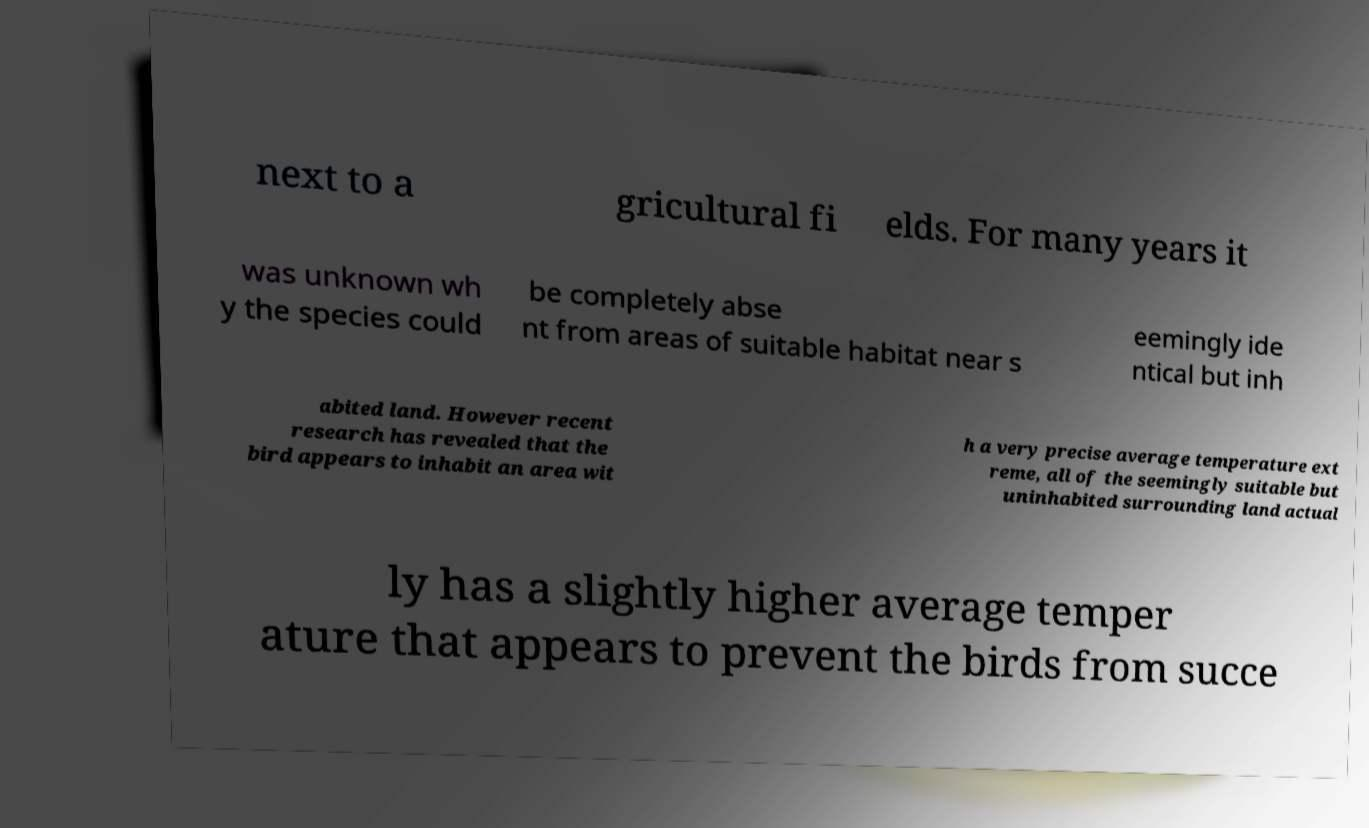Can you accurately transcribe the text from the provided image for me? next to a gricultural fi elds. For many years it was unknown wh y the species could be completely abse nt from areas of suitable habitat near s eemingly ide ntical but inh abited land. However recent research has revealed that the bird appears to inhabit an area wit h a very precise average temperature ext reme, all of the seemingly suitable but uninhabited surrounding land actual ly has a slightly higher average temper ature that appears to prevent the birds from succe 